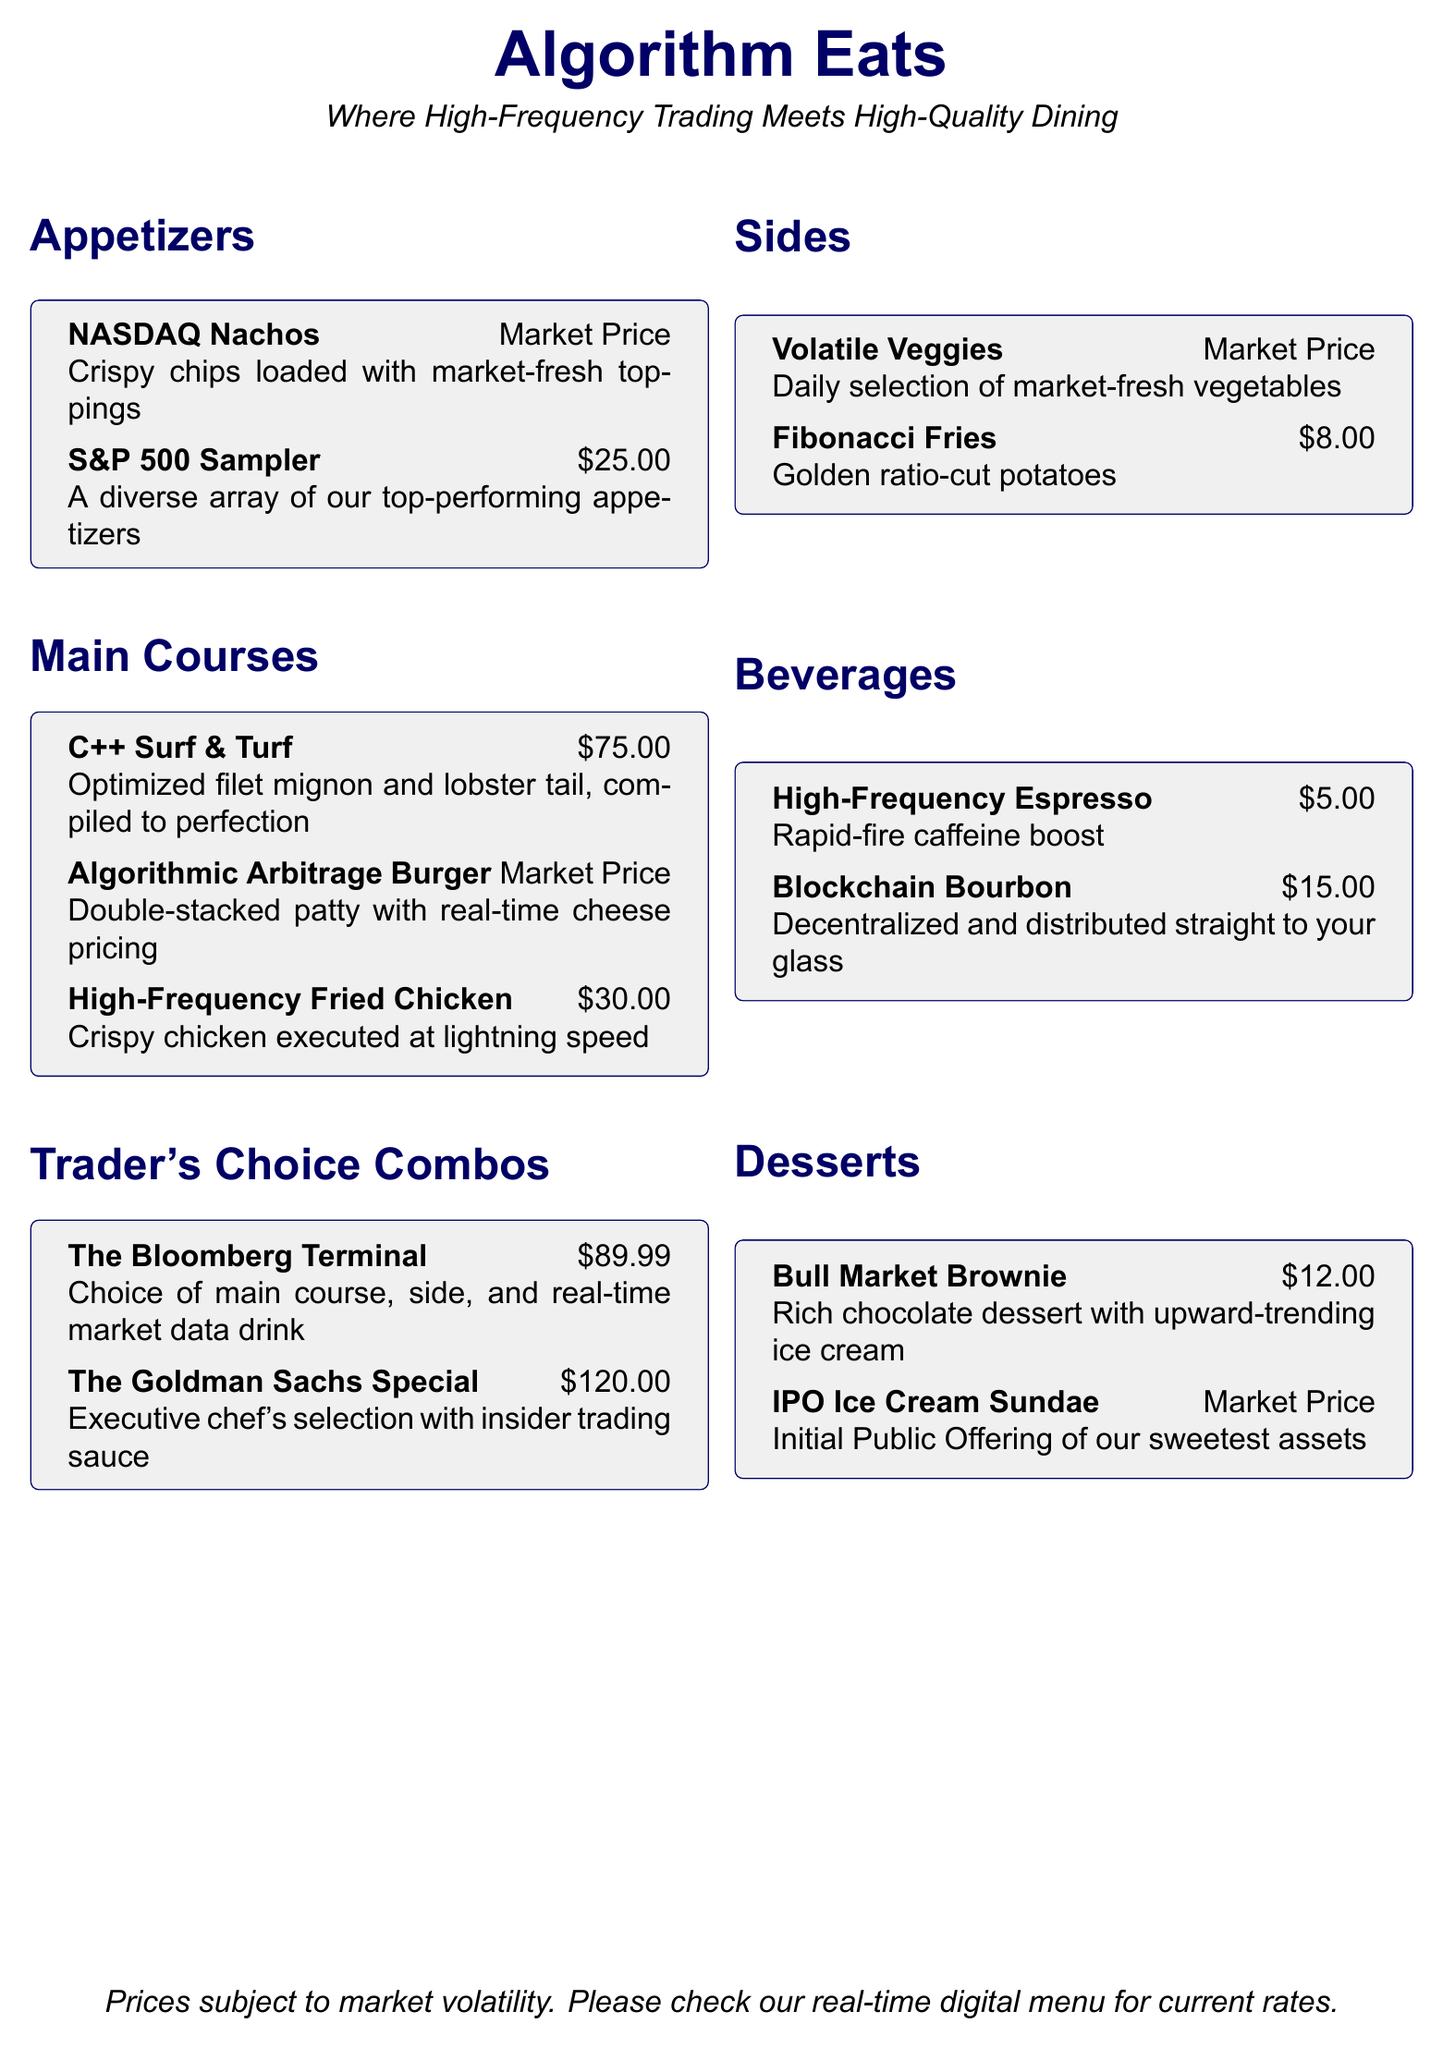what is the price of the C++ Surf & Turf? The price of the C++ Surf & Turf is specifically listed in the Main Courses section.
Answer: $75.00 what are the components of the Bloomberg Terminal? The Bloomberg Terminal includes a choice of main course, side, and a real-time market data drink as stated in the Trader's Choice Combos section.
Answer: Main course, side, real-time market data drink what is the price range for appetizers? The price of appetizers can either be fixed or market price, indicating that the pricing may vary based on the current market conditions.
Answer: Market Price - $25.00 how many types of beverages are listed on the menu? To find the number of beverages, we can count the entries in the Beverages section of the menu.
Answer: 2 which dessert has a market price? The dessert category includes items priced at market price; we look specifically at the desserts listed to find the one.
Answer: IPO Ice Cream Sundae what type of cuisine is represented by High-Frequency Fried Chicken? The name suggests a particular category of dishes represented in the menu, primarily fried items.
Answer: Fried Chicken what is the specific price of Fibonacci Fries? The Fibonacci Fries are listed with an exact price in the Sides section of the menu.
Answer: $8.00 which beverage is associated with a decentralized theme? The beverage description indicates a unique context related to the beverage, connecting it to the theme of decentralization.
Answer: Blockchain Bourbon how many main course options are identified on this menu? We can count the names listed in the Main Courses section of the menu to determine total options.
Answer: 3 